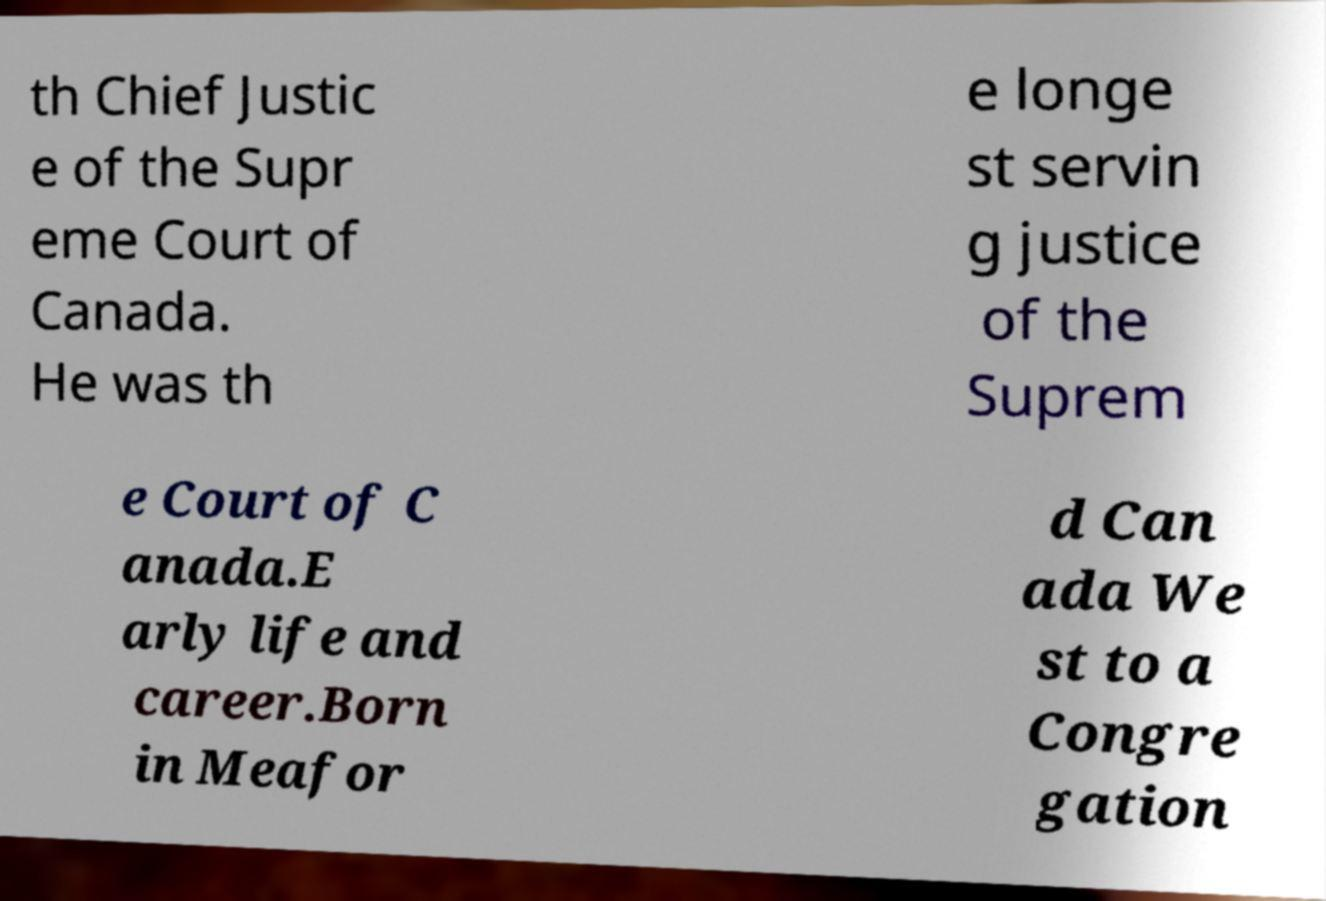Could you assist in decoding the text presented in this image and type it out clearly? th Chief Justic e of the Supr eme Court of Canada. He was th e longe st servin g justice of the Suprem e Court of C anada.E arly life and career.Born in Meafor d Can ada We st to a Congre gation 